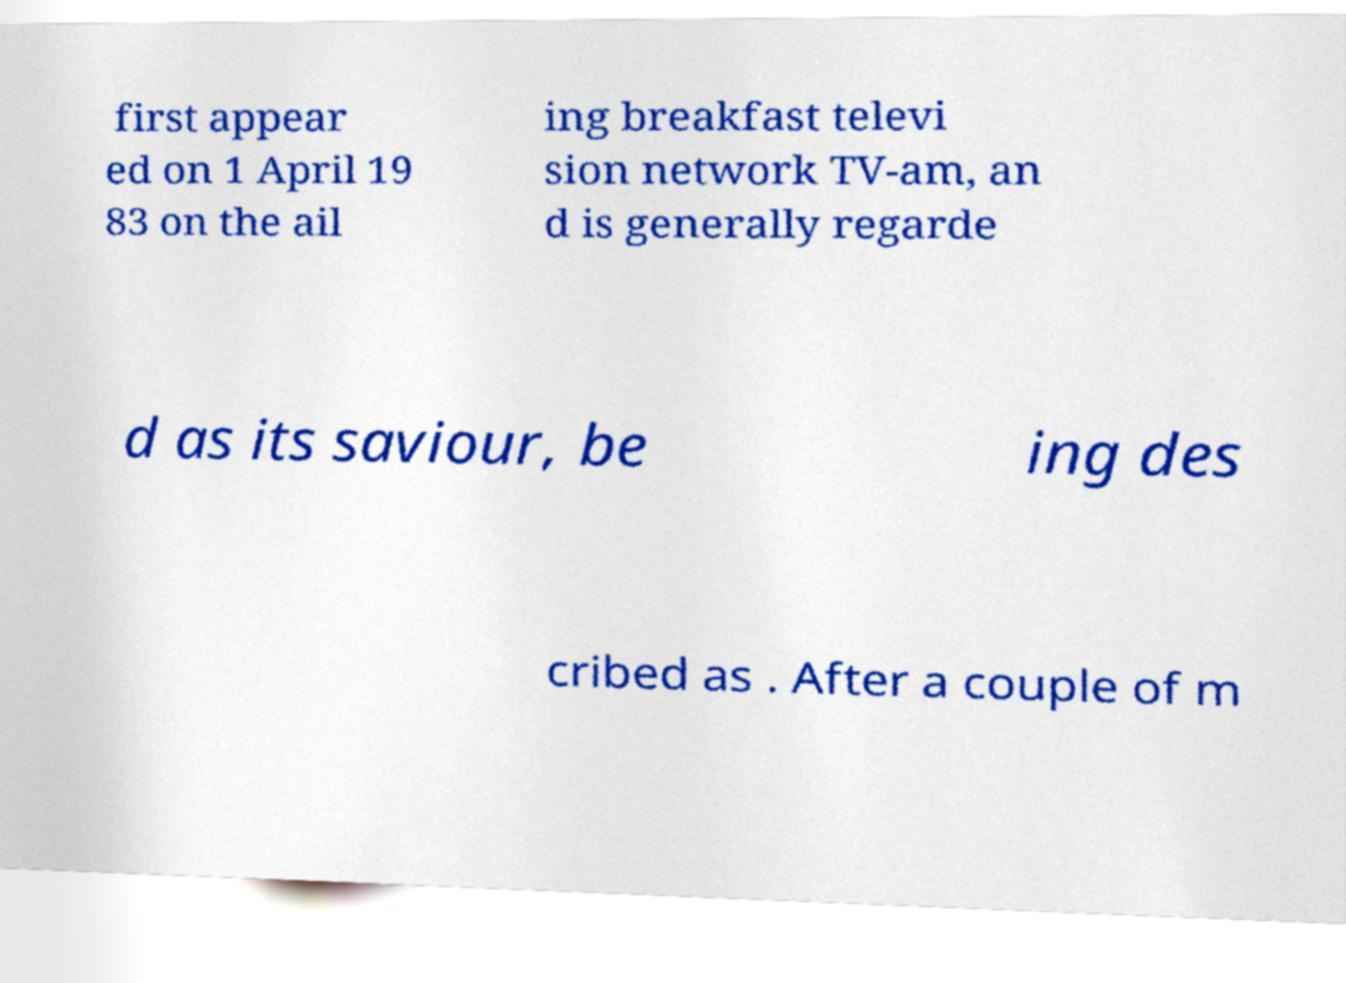Could you assist in decoding the text presented in this image and type it out clearly? first appear ed on 1 April 19 83 on the ail ing breakfast televi sion network TV-am, an d is generally regarde d as its saviour, be ing des cribed as . After a couple of m 